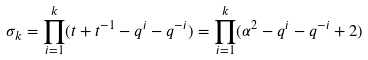Convert formula to latex. <formula><loc_0><loc_0><loc_500><loc_500>\sigma _ { k } = \prod _ { i = 1 } ^ { k } ( t + t ^ { - 1 } - q ^ { i } - q ^ { - i } ) = \prod _ { i = 1 } ^ { k } ( \alpha ^ { 2 } - q ^ { i } - q ^ { - i } + 2 )</formula> 